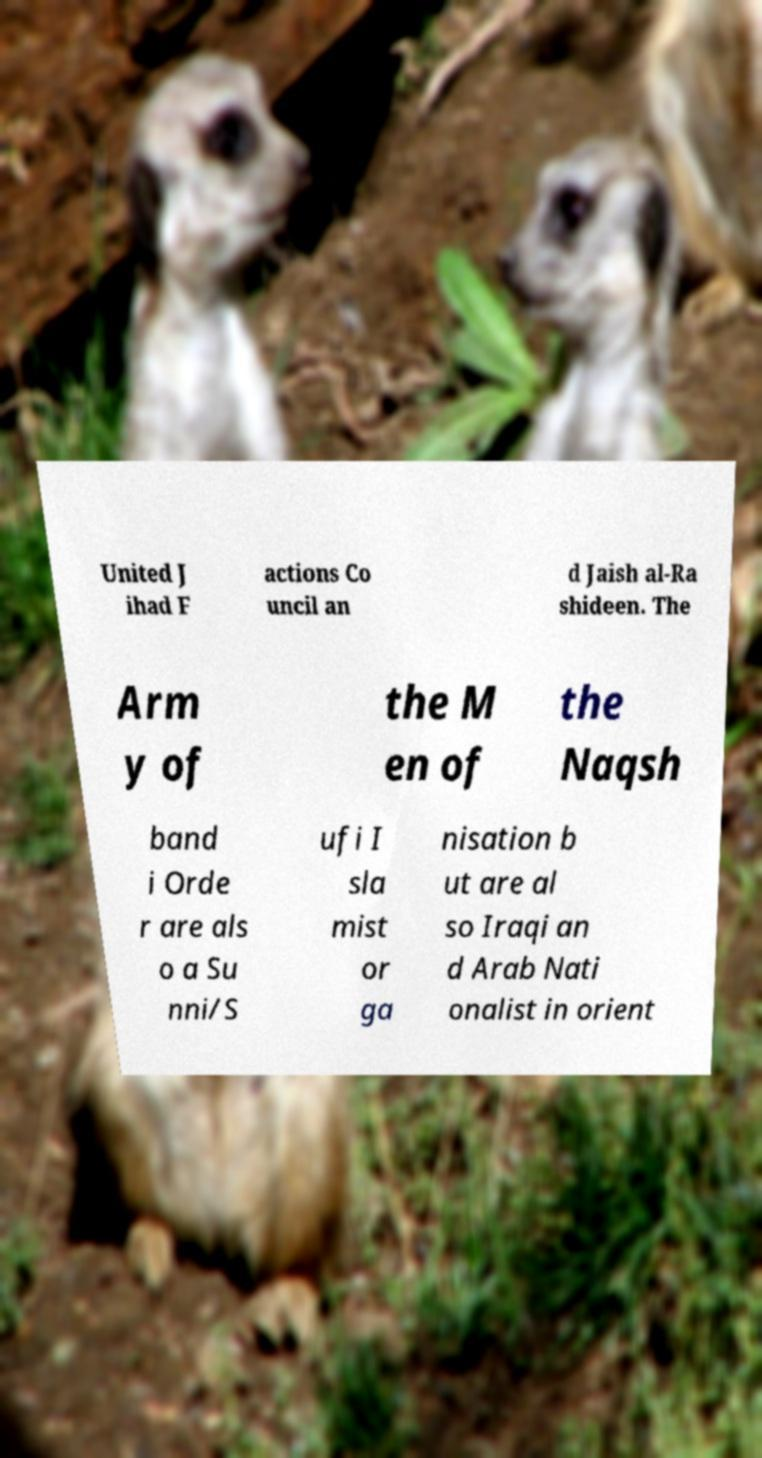Can you accurately transcribe the text from the provided image for me? United J ihad F actions Co uncil an d Jaish al-Ra shideen. The Arm y of the M en of the Naqsh band i Orde r are als o a Su nni/S ufi I sla mist or ga nisation b ut are al so Iraqi an d Arab Nati onalist in orient 